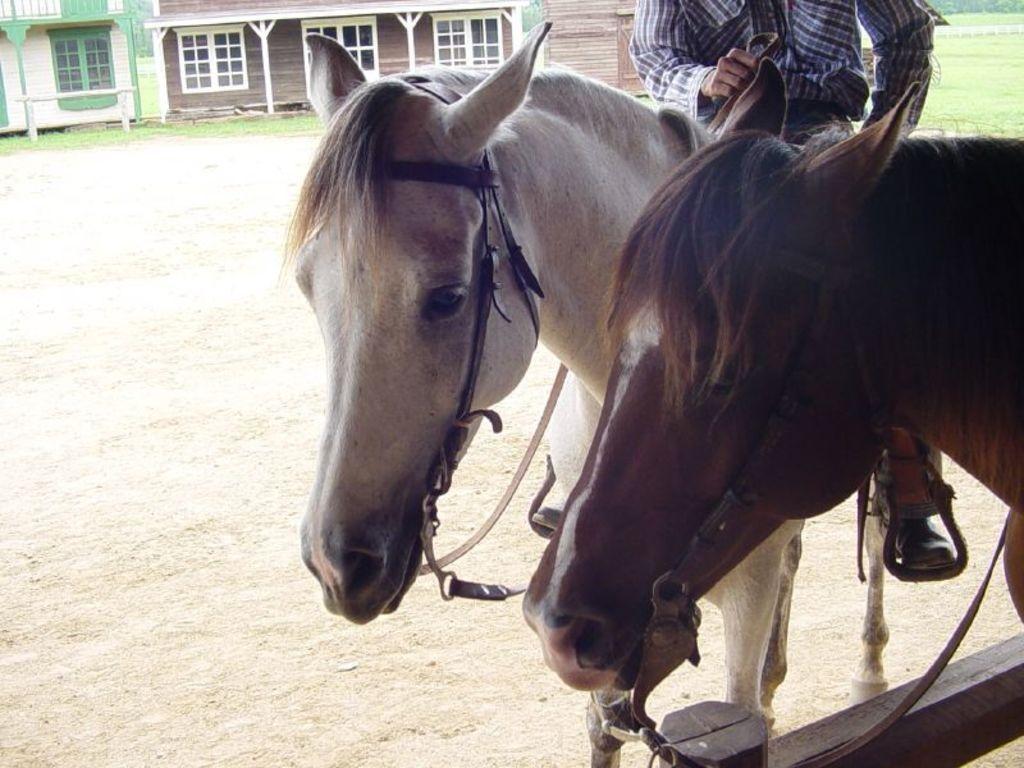In one or two sentences, can you explain what this image depicts? In the right side it's a horse which is in brown color, beside there is another horse which is in white color. In the left side it looks like a house. 